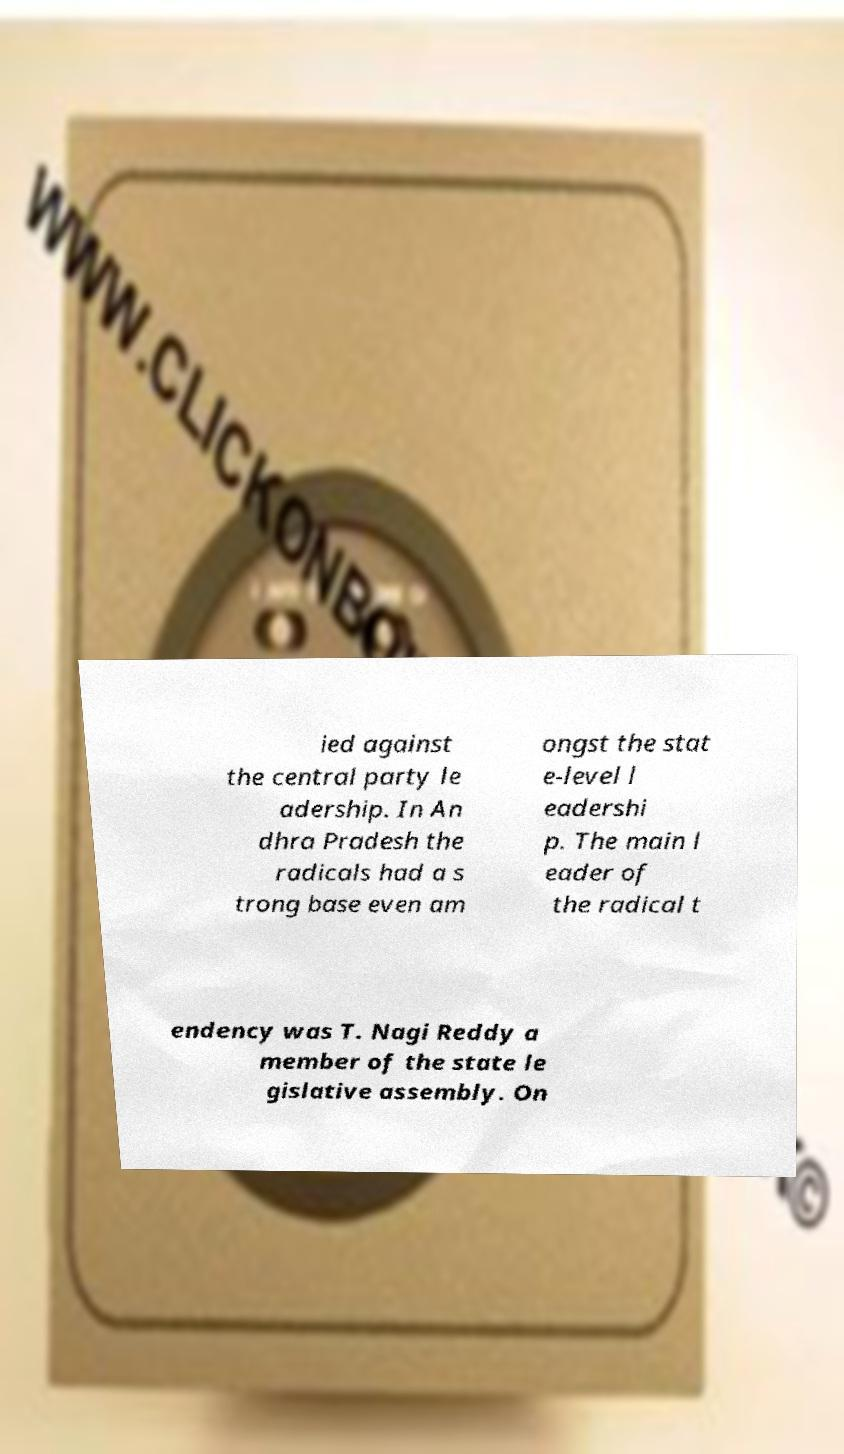I need the written content from this picture converted into text. Can you do that? ied against the central party le adership. In An dhra Pradesh the radicals had a s trong base even am ongst the stat e-level l eadershi p. The main l eader of the radical t endency was T. Nagi Reddy a member of the state le gislative assembly. On 